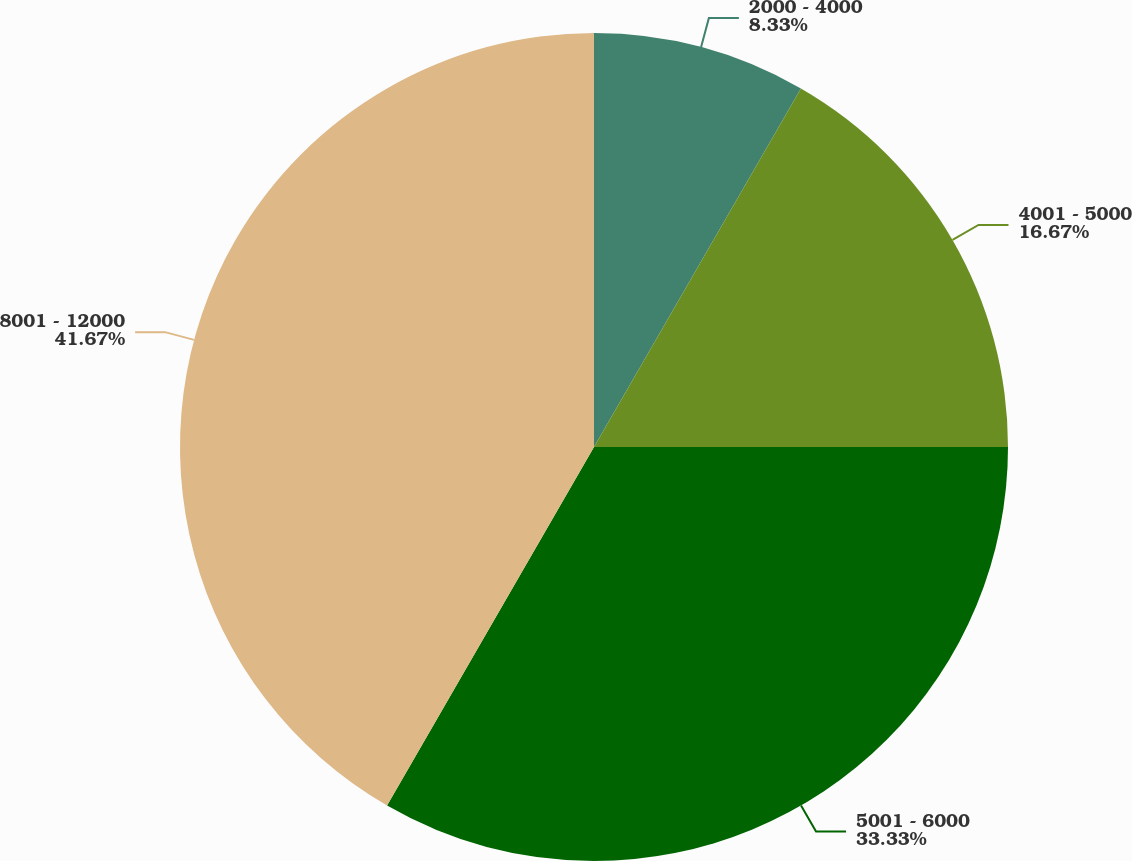<chart> <loc_0><loc_0><loc_500><loc_500><pie_chart><fcel>2000 - 4000<fcel>4001 - 5000<fcel>5001 - 6000<fcel>8001 - 12000<nl><fcel>8.33%<fcel>16.67%<fcel>33.33%<fcel>41.67%<nl></chart> 